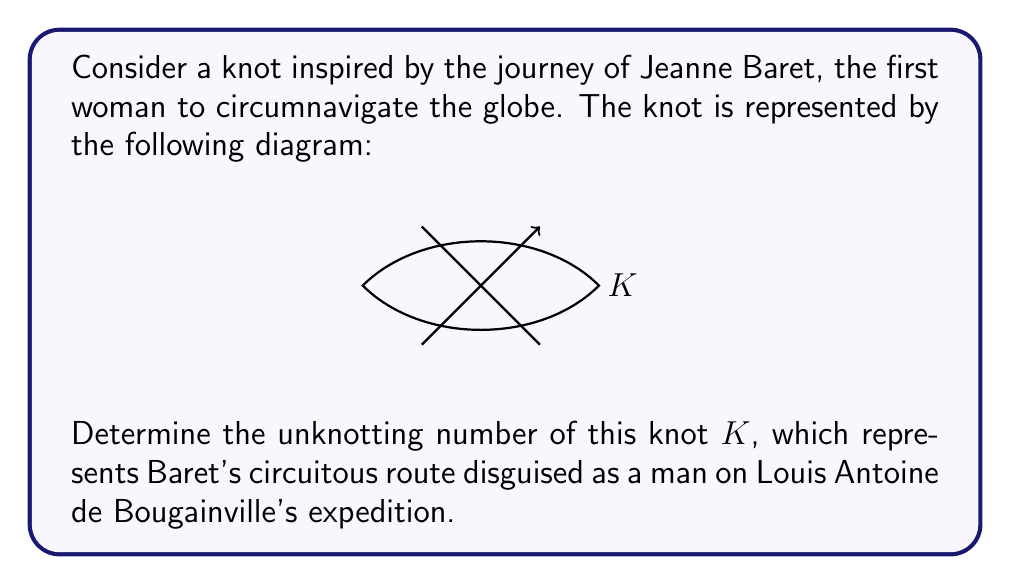Give your solution to this math problem. To determine the unknotting number of the given knot $K$, we'll follow these steps:

1) First, we need to identify the knot type. The diagram shows a trefoil knot with one crossing change.

2) The unknotting number of a knot is the minimum number of crossing changes needed to transform the knot into the unknot (trivial knot).

3) For the trefoil knot, it's known that the unknotting number is 1. This means that changing any one of its crossings will result in the unknot.

4) In our diagram, we can see that one crossing has already been changed (indicated by the arrow). This crossing change transforms the trefoil into the unknot.

5) To verify this, we can mentally perform the indicated crossing change:

   [asy]
   import graph;
   size(200);
   pen p = black+1;
   draw((0,0)..(1,1)..(2,0)..(1,-1)..cycle, p);
   draw((0.5,-0.5)..(1.5,0.5), p);
   [/asy]

   After this change, we can see that the resulting diagram can be deformed into a simple closed loop without any crossings, which is the unknot.

6) Since one crossing change is sufficient to unknot this knot, and we know that the trefoil knot (which this knot was before the crossing change) has an unknotting number of 1, we can conclude that the unknotting number of $K$ is 0.

This aligns with Baret's journey: despite the complexities and obstacles (represented by the original trefoil), her true identity and accomplishments (represented by the unknot) were ultimately revealed with just one key change (her gender being discovered).
Answer: 0 